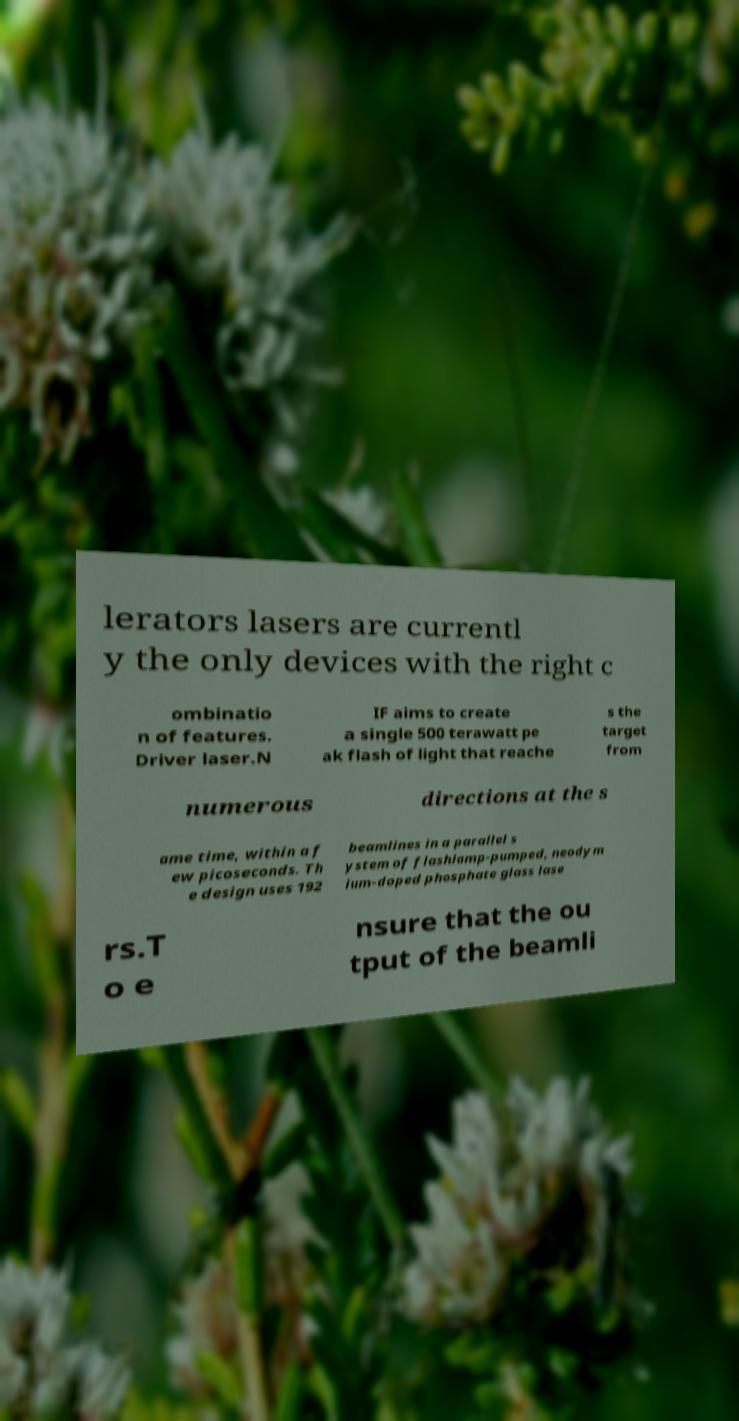Could you assist in decoding the text presented in this image and type it out clearly? lerators lasers are currentl y the only devices with the right c ombinatio n of features. Driver laser.N IF aims to create a single 500 terawatt pe ak flash of light that reache s the target from numerous directions at the s ame time, within a f ew picoseconds. Th e design uses 192 beamlines in a parallel s ystem of flashlamp-pumped, neodym ium-doped phosphate glass lase rs.T o e nsure that the ou tput of the beamli 